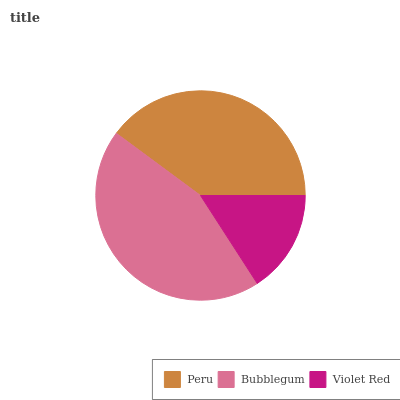Is Violet Red the minimum?
Answer yes or no. Yes. Is Bubblegum the maximum?
Answer yes or no. Yes. Is Bubblegum the minimum?
Answer yes or no. No. Is Violet Red the maximum?
Answer yes or no. No. Is Bubblegum greater than Violet Red?
Answer yes or no. Yes. Is Violet Red less than Bubblegum?
Answer yes or no. Yes. Is Violet Red greater than Bubblegum?
Answer yes or no. No. Is Bubblegum less than Violet Red?
Answer yes or no. No. Is Peru the high median?
Answer yes or no. Yes. Is Peru the low median?
Answer yes or no. Yes. Is Bubblegum the high median?
Answer yes or no. No. Is Bubblegum the low median?
Answer yes or no. No. 